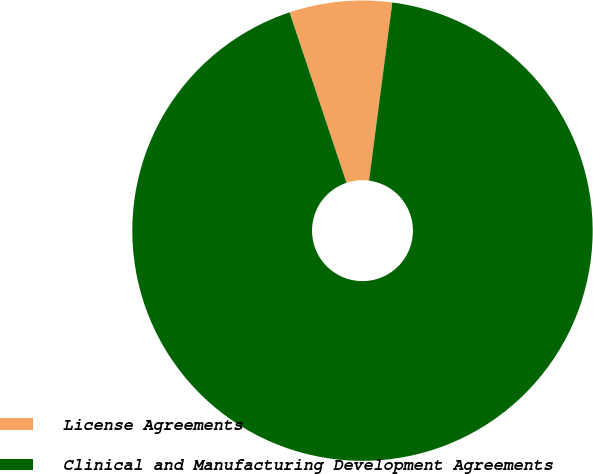<chart> <loc_0><loc_0><loc_500><loc_500><pie_chart><fcel>License Agreements<fcel>Clinical and Manufacturing Development Agreements<nl><fcel>7.2%<fcel>92.8%<nl></chart> 